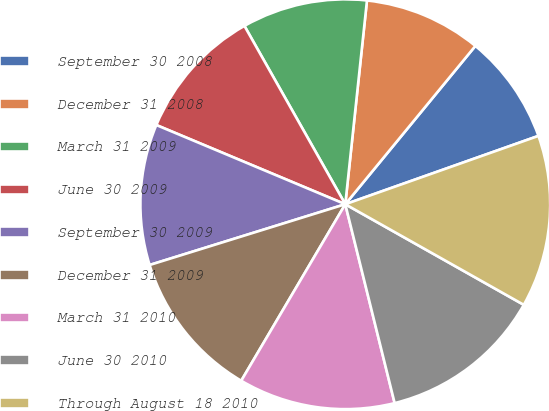Convert chart to OTSL. <chart><loc_0><loc_0><loc_500><loc_500><pie_chart><fcel>September 30 2008<fcel>December 31 2008<fcel>March 31 2009<fcel>June 30 2009<fcel>September 30 2009<fcel>December 31 2009<fcel>March 31 2010<fcel>June 30 2010<fcel>Through August 18 2010<nl><fcel>8.64%<fcel>9.26%<fcel>9.88%<fcel>10.49%<fcel>11.11%<fcel>11.73%<fcel>12.35%<fcel>12.96%<fcel>13.58%<nl></chart> 